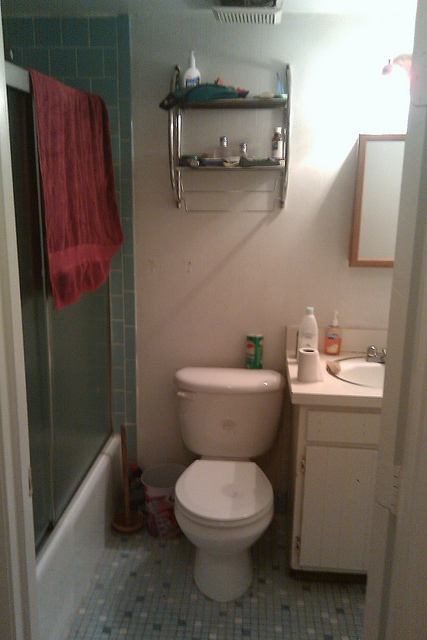What kind of unexpected event could happen in this bathroom? An unexpected event in this bathroom could be a sudden malfunction of the plumbing, causing the toilet to overflow. This might lead to water quickly spreading onto the floor, causing panic and immediate action to turn off the water supply and mop up the mess. Alternatively, one might discover a friendly yet adventurous mouse that has found its way into the bathroom, causing a surprise and a series of attempts to safely capture and release the little visitor outside.  What if the bathroom turned into a portal to a magical underwater world every time someone took a shower? Imagine stepping into the shower in this bathroom, and the moment you turn on the water, the tiles shimmer and dissolve, revealing a portal to a breathtaking underwater world. As the water cascades over you, you find yourself surrounded by vibrant coral reefs, luminous sea creatures, and the gentle current of an enchanting ocean. You can breathe easily and move freely, exploring underwater palaces, meeting mystical mermaids, and discovering hidden treasures. Time seems to stand still in this magical realm, offering a serene escape from the ordinary world each time you take a shower. Eventually, as the water stops, the bathroom reappears, leaving only a memory of the underwater adventure. 